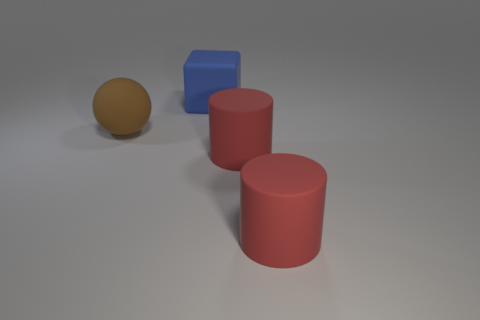Add 2 blue cubes. How many objects exist? 6 Subtract all blocks. How many objects are left? 3 Add 4 big matte cylinders. How many big matte cylinders are left? 6 Add 2 large brown metallic cubes. How many large brown metallic cubes exist? 2 Subtract 0 red cubes. How many objects are left? 4 Subtract all big red cylinders. Subtract all large rubber cylinders. How many objects are left? 0 